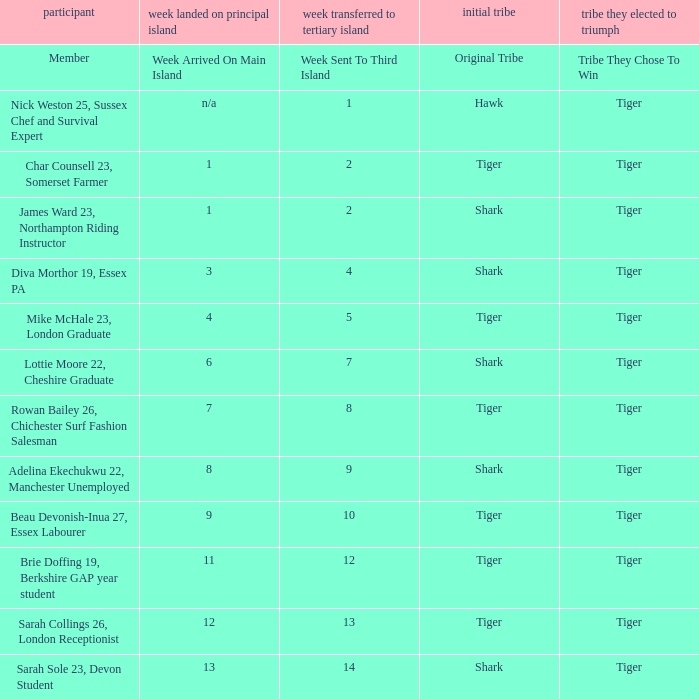In week 4, how many members made it to the main island? 1.0. 